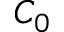Convert formula to latex. <formula><loc_0><loc_0><loc_500><loc_500>C _ { 0 }</formula> 